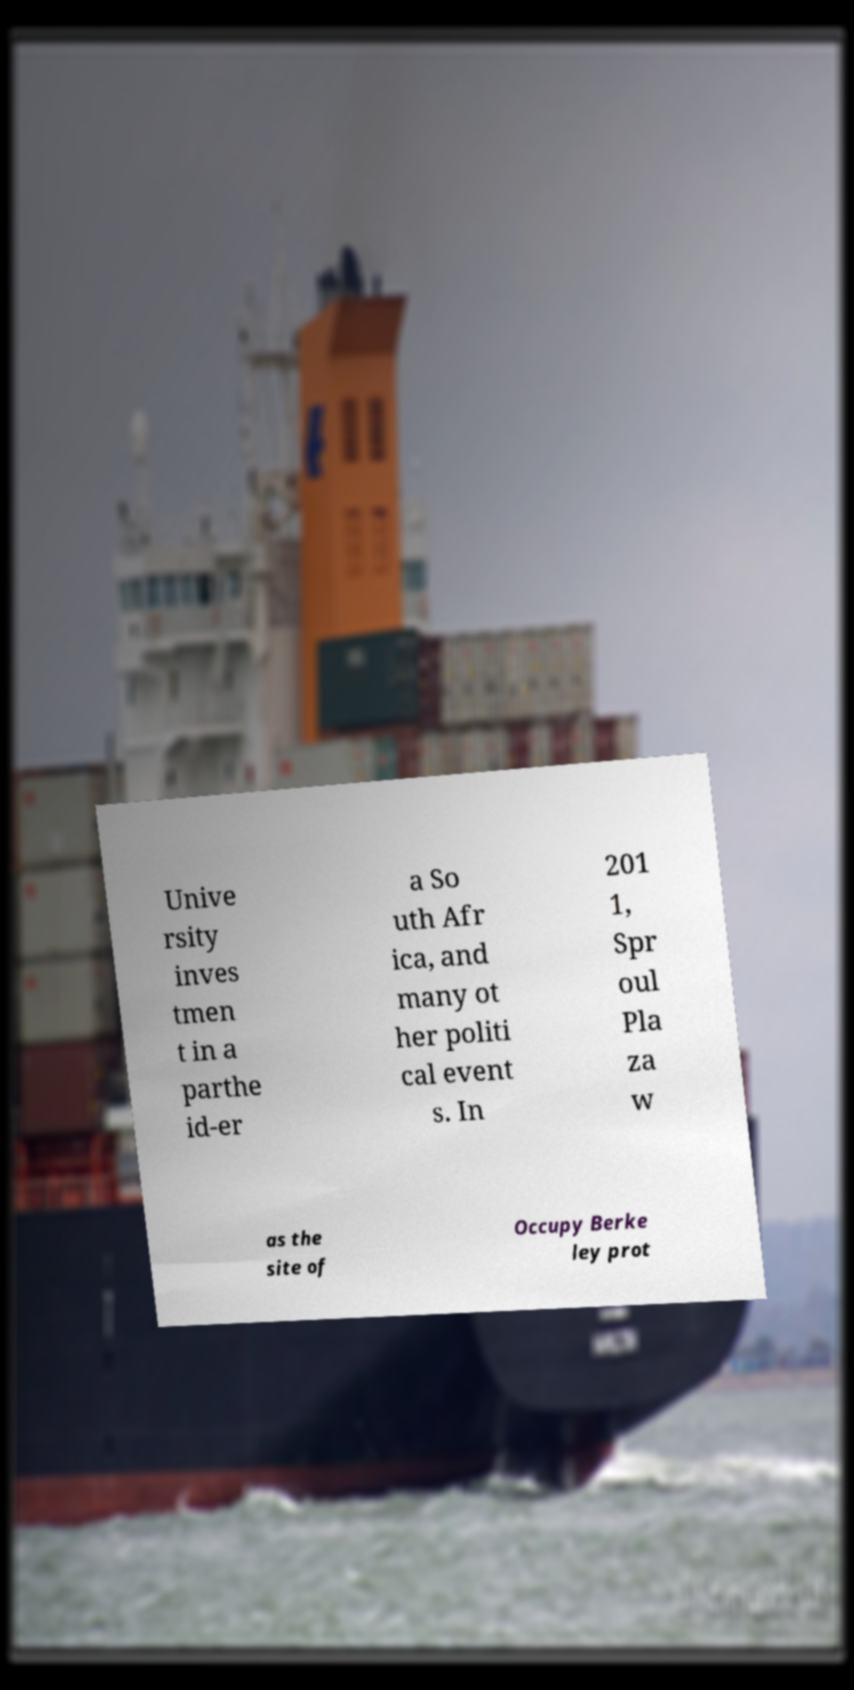Could you assist in decoding the text presented in this image and type it out clearly? Unive rsity inves tmen t in a parthe id-er a So uth Afr ica, and many ot her politi cal event s. In 201 1, Spr oul Pla za w as the site of Occupy Berke ley prot 